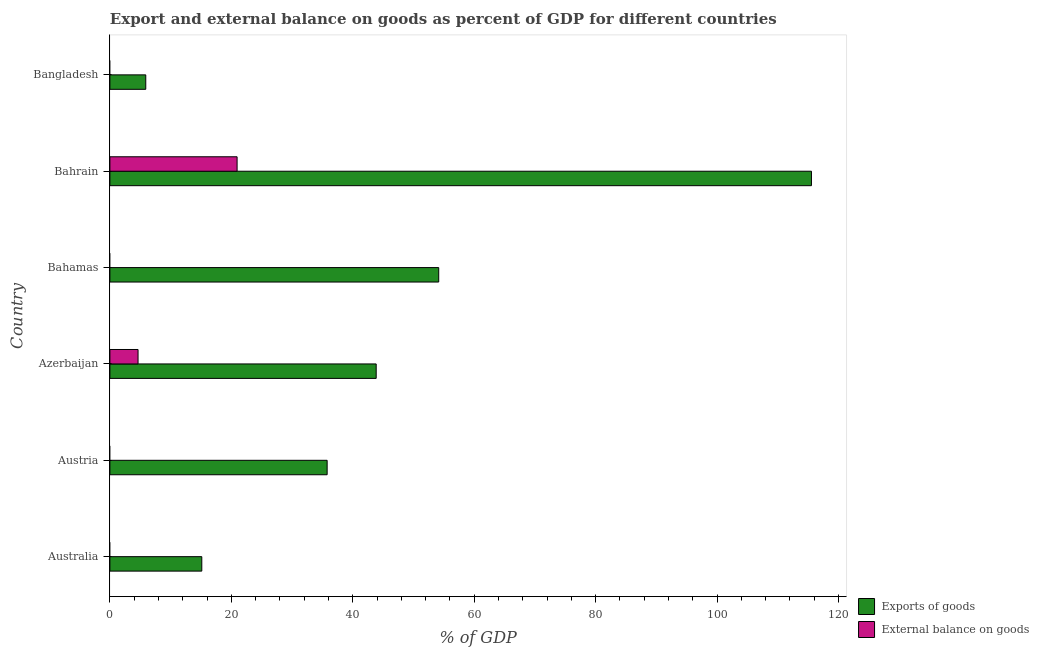How many different coloured bars are there?
Make the answer very short. 2. Are the number of bars per tick equal to the number of legend labels?
Offer a terse response. No. How many bars are there on the 6th tick from the bottom?
Offer a terse response. 1. What is the label of the 1st group of bars from the top?
Give a very brief answer. Bangladesh. In how many cases, is the number of bars for a given country not equal to the number of legend labels?
Your answer should be very brief. 4. What is the export of goods as percentage of gdp in Bahamas?
Offer a very short reply. 54.16. Across all countries, what is the maximum export of goods as percentage of gdp?
Your answer should be compact. 115.56. Across all countries, what is the minimum external balance on goods as percentage of gdp?
Give a very brief answer. 0. In which country was the export of goods as percentage of gdp maximum?
Offer a very short reply. Bahrain. What is the total export of goods as percentage of gdp in the graph?
Make the answer very short. 270.41. What is the difference between the export of goods as percentage of gdp in Azerbaijan and that in Bangladesh?
Offer a very short reply. 37.95. What is the difference between the export of goods as percentage of gdp in Austria and the external balance on goods as percentage of gdp in Azerbaijan?
Give a very brief answer. 31.15. What is the average export of goods as percentage of gdp per country?
Your answer should be very brief. 45.07. What is the difference between the export of goods as percentage of gdp and external balance on goods as percentage of gdp in Bahrain?
Your answer should be compact. 94.61. In how many countries, is the external balance on goods as percentage of gdp greater than 84 %?
Offer a terse response. 0. What is the ratio of the export of goods as percentage of gdp in Australia to that in Bahrain?
Provide a short and direct response. 0.13. What is the difference between the highest and the second highest export of goods as percentage of gdp?
Offer a terse response. 61.4. What is the difference between the highest and the lowest external balance on goods as percentage of gdp?
Your response must be concise. 20.95. In how many countries, is the external balance on goods as percentage of gdp greater than the average external balance on goods as percentage of gdp taken over all countries?
Make the answer very short. 2. Are all the bars in the graph horizontal?
Your response must be concise. Yes. How many countries are there in the graph?
Provide a short and direct response. 6. What is the difference between two consecutive major ticks on the X-axis?
Offer a very short reply. 20. Are the values on the major ticks of X-axis written in scientific E-notation?
Offer a terse response. No. Does the graph contain any zero values?
Offer a terse response. Yes. Does the graph contain grids?
Make the answer very short. No. How many legend labels are there?
Ensure brevity in your answer.  2. How are the legend labels stacked?
Your answer should be compact. Vertical. What is the title of the graph?
Your answer should be very brief. Export and external balance on goods as percent of GDP for different countries. Does "Private credit bureau" appear as one of the legend labels in the graph?
Your answer should be compact. No. What is the label or title of the X-axis?
Keep it short and to the point. % of GDP. What is the label or title of the Y-axis?
Offer a terse response. Country. What is the % of GDP in Exports of goods in Australia?
Ensure brevity in your answer.  15.14. What is the % of GDP in Exports of goods in Austria?
Give a very brief answer. 35.78. What is the % of GDP in Exports of goods in Azerbaijan?
Give a very brief answer. 43.86. What is the % of GDP of External balance on goods in Azerbaijan?
Provide a short and direct response. 4.64. What is the % of GDP in Exports of goods in Bahamas?
Your answer should be very brief. 54.16. What is the % of GDP of External balance on goods in Bahamas?
Offer a very short reply. 0. What is the % of GDP in Exports of goods in Bahrain?
Your answer should be very brief. 115.56. What is the % of GDP in External balance on goods in Bahrain?
Offer a terse response. 20.95. What is the % of GDP of Exports of goods in Bangladesh?
Offer a terse response. 5.91. What is the % of GDP in External balance on goods in Bangladesh?
Offer a terse response. 0. Across all countries, what is the maximum % of GDP of Exports of goods?
Your response must be concise. 115.56. Across all countries, what is the maximum % of GDP in External balance on goods?
Your response must be concise. 20.95. Across all countries, what is the minimum % of GDP of Exports of goods?
Give a very brief answer. 5.91. What is the total % of GDP in Exports of goods in the graph?
Keep it short and to the point. 270.41. What is the total % of GDP of External balance on goods in the graph?
Your response must be concise. 25.59. What is the difference between the % of GDP in Exports of goods in Australia and that in Austria?
Your answer should be very brief. -20.65. What is the difference between the % of GDP of Exports of goods in Australia and that in Azerbaijan?
Offer a terse response. -28.72. What is the difference between the % of GDP in Exports of goods in Australia and that in Bahamas?
Your response must be concise. -39.02. What is the difference between the % of GDP of Exports of goods in Australia and that in Bahrain?
Offer a very short reply. -100.42. What is the difference between the % of GDP in Exports of goods in Australia and that in Bangladesh?
Provide a short and direct response. 9.23. What is the difference between the % of GDP of Exports of goods in Austria and that in Azerbaijan?
Offer a very short reply. -8.08. What is the difference between the % of GDP of Exports of goods in Austria and that in Bahamas?
Your answer should be very brief. -18.38. What is the difference between the % of GDP of Exports of goods in Austria and that in Bahrain?
Your response must be concise. -79.77. What is the difference between the % of GDP in Exports of goods in Austria and that in Bangladesh?
Give a very brief answer. 29.88. What is the difference between the % of GDP of Exports of goods in Azerbaijan and that in Bahamas?
Offer a terse response. -10.3. What is the difference between the % of GDP in Exports of goods in Azerbaijan and that in Bahrain?
Ensure brevity in your answer.  -71.69. What is the difference between the % of GDP of External balance on goods in Azerbaijan and that in Bahrain?
Your answer should be compact. -16.31. What is the difference between the % of GDP of Exports of goods in Azerbaijan and that in Bangladesh?
Keep it short and to the point. 37.95. What is the difference between the % of GDP of Exports of goods in Bahamas and that in Bahrain?
Make the answer very short. -61.4. What is the difference between the % of GDP of Exports of goods in Bahamas and that in Bangladesh?
Your answer should be very brief. 48.25. What is the difference between the % of GDP of Exports of goods in Bahrain and that in Bangladesh?
Provide a short and direct response. 109.65. What is the difference between the % of GDP in Exports of goods in Australia and the % of GDP in External balance on goods in Azerbaijan?
Your response must be concise. 10.5. What is the difference between the % of GDP of Exports of goods in Australia and the % of GDP of External balance on goods in Bahrain?
Offer a very short reply. -5.81. What is the difference between the % of GDP in Exports of goods in Austria and the % of GDP in External balance on goods in Azerbaijan?
Give a very brief answer. 31.15. What is the difference between the % of GDP of Exports of goods in Austria and the % of GDP of External balance on goods in Bahrain?
Make the answer very short. 14.83. What is the difference between the % of GDP of Exports of goods in Azerbaijan and the % of GDP of External balance on goods in Bahrain?
Your response must be concise. 22.91. What is the difference between the % of GDP in Exports of goods in Bahamas and the % of GDP in External balance on goods in Bahrain?
Keep it short and to the point. 33.21. What is the average % of GDP of Exports of goods per country?
Your answer should be very brief. 45.07. What is the average % of GDP of External balance on goods per country?
Your answer should be very brief. 4.26. What is the difference between the % of GDP of Exports of goods and % of GDP of External balance on goods in Azerbaijan?
Your answer should be compact. 39.22. What is the difference between the % of GDP of Exports of goods and % of GDP of External balance on goods in Bahrain?
Your answer should be very brief. 94.61. What is the ratio of the % of GDP of Exports of goods in Australia to that in Austria?
Give a very brief answer. 0.42. What is the ratio of the % of GDP of Exports of goods in Australia to that in Azerbaijan?
Your answer should be very brief. 0.35. What is the ratio of the % of GDP of Exports of goods in Australia to that in Bahamas?
Your answer should be compact. 0.28. What is the ratio of the % of GDP in Exports of goods in Australia to that in Bahrain?
Your answer should be very brief. 0.13. What is the ratio of the % of GDP in Exports of goods in Australia to that in Bangladesh?
Offer a terse response. 2.56. What is the ratio of the % of GDP in Exports of goods in Austria to that in Azerbaijan?
Provide a succinct answer. 0.82. What is the ratio of the % of GDP in Exports of goods in Austria to that in Bahamas?
Provide a succinct answer. 0.66. What is the ratio of the % of GDP in Exports of goods in Austria to that in Bahrain?
Provide a succinct answer. 0.31. What is the ratio of the % of GDP in Exports of goods in Austria to that in Bangladesh?
Make the answer very short. 6.06. What is the ratio of the % of GDP of Exports of goods in Azerbaijan to that in Bahamas?
Provide a short and direct response. 0.81. What is the ratio of the % of GDP of Exports of goods in Azerbaijan to that in Bahrain?
Provide a succinct answer. 0.38. What is the ratio of the % of GDP in External balance on goods in Azerbaijan to that in Bahrain?
Your response must be concise. 0.22. What is the ratio of the % of GDP in Exports of goods in Azerbaijan to that in Bangladesh?
Provide a succinct answer. 7.42. What is the ratio of the % of GDP of Exports of goods in Bahamas to that in Bahrain?
Provide a succinct answer. 0.47. What is the ratio of the % of GDP of Exports of goods in Bahamas to that in Bangladesh?
Offer a very short reply. 9.17. What is the ratio of the % of GDP of Exports of goods in Bahrain to that in Bangladesh?
Ensure brevity in your answer.  19.56. What is the difference between the highest and the second highest % of GDP of Exports of goods?
Keep it short and to the point. 61.4. What is the difference between the highest and the lowest % of GDP in Exports of goods?
Provide a short and direct response. 109.65. What is the difference between the highest and the lowest % of GDP in External balance on goods?
Your response must be concise. 20.95. 